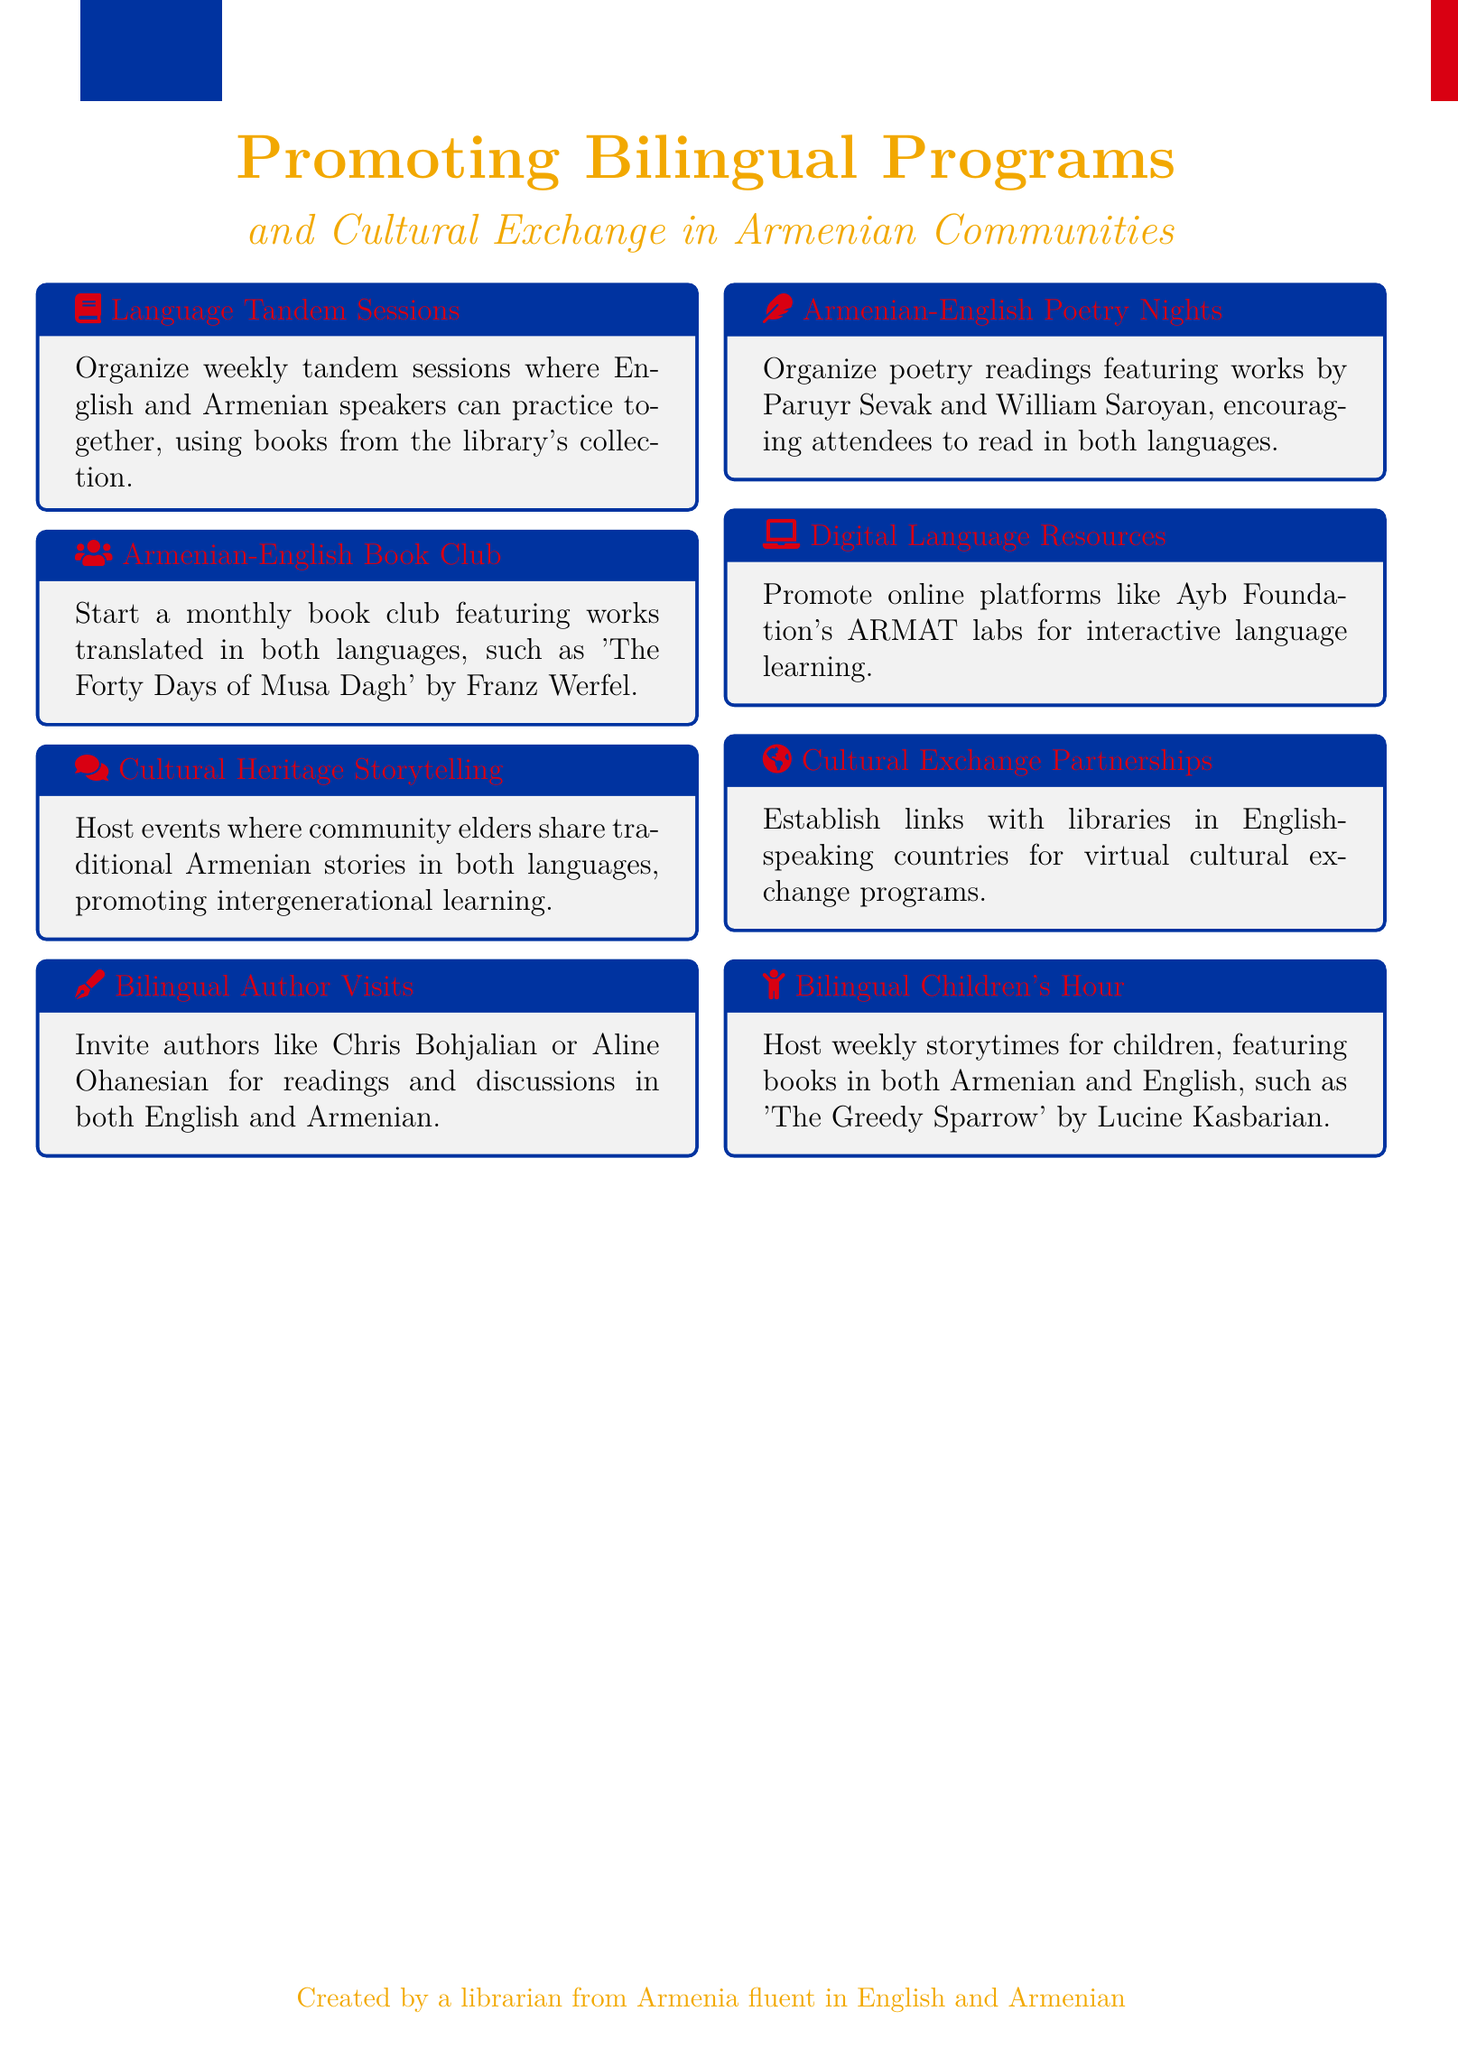What is the title of the document? The title of the document summarizes its focus on bilingual reading programs and cultural exchange in Armenian communities.
Answer: Promoting Bilingual Reading Programs and Cultural Exchange in Armenian Communities How often will the tandem sessions be held? The document specifies the frequency of the tandem sessions as weekly.
Answer: Weekly Who is a suggested author for bilingual visits? The document mentions specific authors as examples for bilingual author visits, indicating they are noteworthy in this context.
Answer: Chris Bohjalian What type of activities will be featured in the Armenian-English Book Club? The document suggests that the book club will feature works translated in both languages.
Answer: Works translated in both languages What is the purpose of the Cultural Heritage Storytelling events? The document states that these events promote intergenerational learning through storytelling.
Answer: Promote intergenerational learning What age group is the Bilingual Children's Hour aimed at? The document indicates this program is specifically for children, focusing on their storytime activities.
Answer: Children What is the name of a book suggested for the Bilingual Children's Hour? The document provides an example of a book for this program, showcasing its bilingual reading aim.
Answer: The Greedy Sparrow How many ideas are presented in the document? A count of the key points in the document reveals the total number of ideas related to promoting bilingual programs.
Answer: Eight 